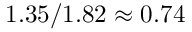<formula> <loc_0><loc_0><loc_500><loc_500>1 . 3 5 / 1 . 8 2 \approx 0 . 7 4</formula> 